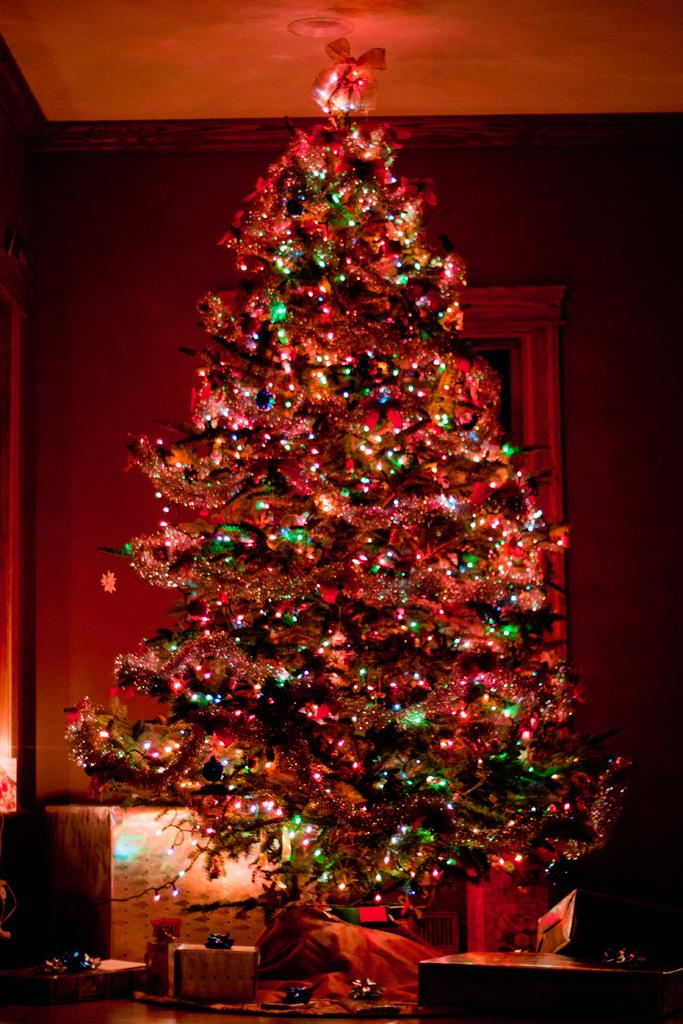What type of tree is in the image? There is a Christmas tree in the image. What is on the table in the image? There are gift boxes on a table in the image. Can you describe the location of the other box in the image? There is another box behind the Christmas tree in the image. What type of guide is present in the image? There is no guide present in the image. Is there a recess in the image? There is no recess mentioned or visible in the image. 